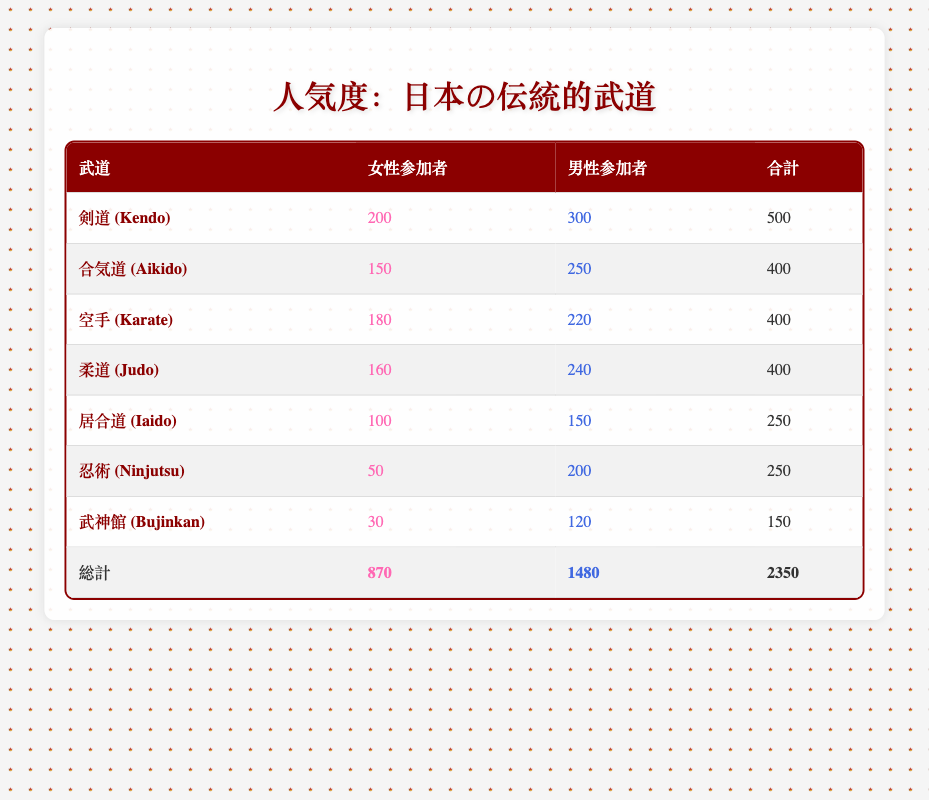What is the total number of female participants in all martial arts? To find the total number of female participants, we sum the values from the female participants column: (200 + 150 + 180 + 160 + 100 + 50 + 30) = 870
Answer: 870 Which martial art has the highest number of male participants? Looking at the male participants column, Kendo has 300 participants, which is higher than the others: Aikido (250), Karate (220), Judo (240), Iaido (150), Ninjutsu (200), and Bujinkan (120). Thus, Kendo has the highest number.
Answer: Kendo What is the combined total number of participants for Karate and Judo? We add the total participants of Karate (400) and Judo (400): 400 + 400 = 800.
Answer: 800 True or False: Aikido has more female participants than Iaido. Aikido has 150 female participants whereas Iaido has only 100. Since 150 > 100, the statement is true.
Answer: True What percentage of the total participants are female? First, we find the total participants: 2350 (sum of all participants). The number of female participants is 870. To find the percentage, we calculate (870 / 2350) * 100 = 37.0%.
Answer: 37.0% Which martial art has the smallest number of total participants? We calculate the total for each martial art: Kendo (500), Aikido (400), Karate (400), Judo (400), Iaido (250), Ninjutsu (250), and Bujinkan (150). Bujinkan has the smallest total of 150.
Answer: Bujinkan If we combine the female participants of Karate and Ninjutsu, how many are there? The female participants for Karate is 180 and for Ninjutsu it is 50. Adding these gives us: 180 + 50 = 230.
Answer: 230 What is the ratio of male participants to female participants across all martial arts? First, we have a total of 1480 male participants and 870 female participants. The ratio is 1480:870, which can be simplified by dividing both sides by 10, yielding a ratio of 148:87.
Answer: 148:87 